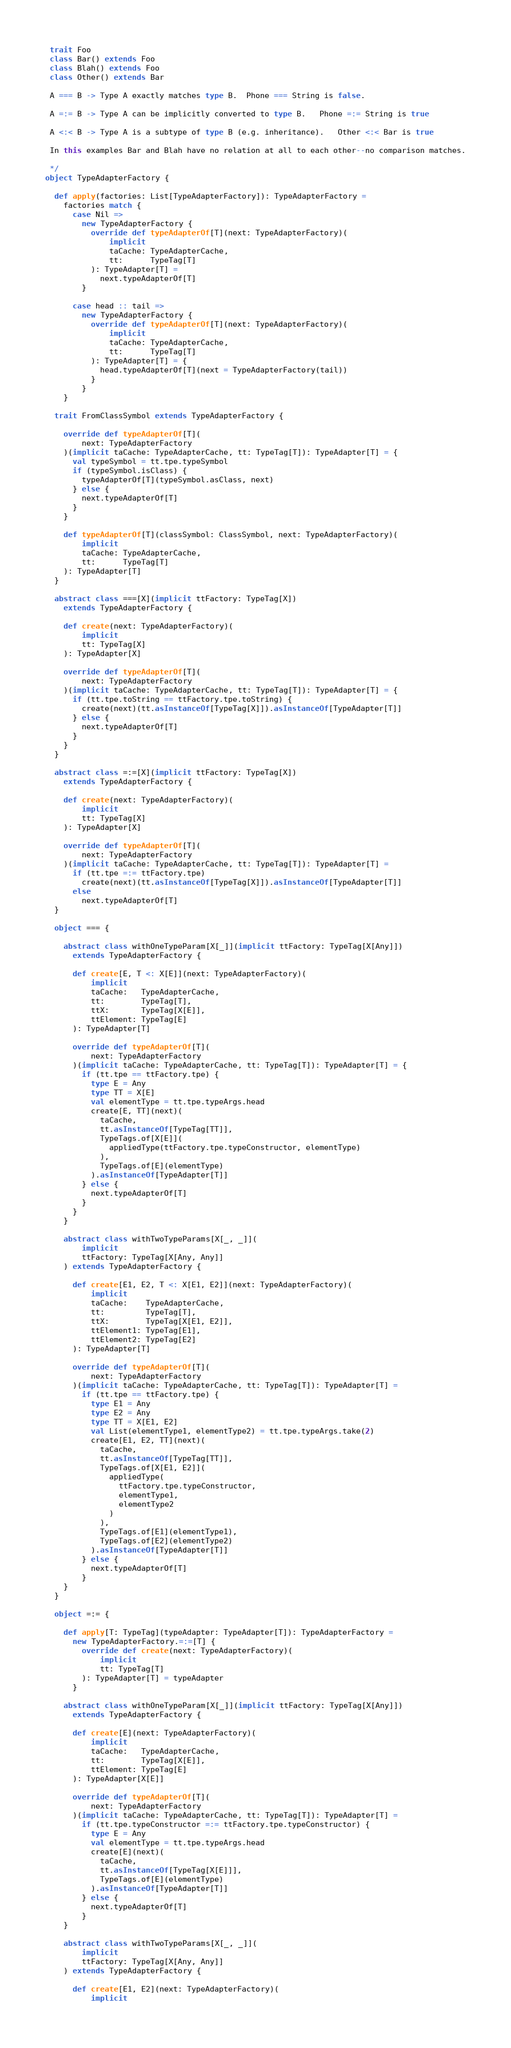<code> <loc_0><loc_0><loc_500><loc_500><_Scala_> trait Foo
 class Bar() extends Foo
 class Blah() extends Foo
 class Other() extends Bar

 A === B -> Type A exactly matches type B.  Phone === String is false.

 A =:= B -> Type A can be implicitly converted to type B.   Phone =:= String is true

 A <:< B -> Type A is a subtype of type B (e.g. inheritance).   Other <:< Bar is true

 In this examples Bar and Blah have no relation at all to each other--no comparison matches.

 */
object TypeAdapterFactory {

  def apply(factories: List[TypeAdapterFactory]): TypeAdapterFactory =
    factories match {
      case Nil =>
        new TypeAdapterFactory {
          override def typeAdapterOf[T](next: TypeAdapterFactory)(
              implicit
              taCache: TypeAdapterCache,
              tt:      TypeTag[T]
          ): TypeAdapter[T] =
            next.typeAdapterOf[T]
        }

      case head :: tail =>
        new TypeAdapterFactory {
          override def typeAdapterOf[T](next: TypeAdapterFactory)(
              implicit
              taCache: TypeAdapterCache,
              tt:      TypeTag[T]
          ): TypeAdapter[T] = {
            head.typeAdapterOf[T](next = TypeAdapterFactory(tail))
          }
        }
    }

  trait FromClassSymbol extends TypeAdapterFactory {

    override def typeAdapterOf[T](
        next: TypeAdapterFactory
    )(implicit taCache: TypeAdapterCache, tt: TypeTag[T]): TypeAdapter[T] = {
      val typeSymbol = tt.tpe.typeSymbol
      if (typeSymbol.isClass) {
        typeAdapterOf[T](typeSymbol.asClass, next)
      } else {
        next.typeAdapterOf[T]
      }
    }

    def typeAdapterOf[T](classSymbol: ClassSymbol, next: TypeAdapterFactory)(
        implicit
        taCache: TypeAdapterCache,
        tt:      TypeTag[T]
    ): TypeAdapter[T]
  }

  abstract class ===[X](implicit ttFactory: TypeTag[X])
    extends TypeAdapterFactory {

    def create(next: TypeAdapterFactory)(
        implicit
        tt: TypeTag[X]
    ): TypeAdapter[X]

    override def typeAdapterOf[T](
        next: TypeAdapterFactory
    )(implicit taCache: TypeAdapterCache, tt: TypeTag[T]): TypeAdapter[T] = {
      if (tt.tpe.toString == ttFactory.tpe.toString) {
        create(next)(tt.asInstanceOf[TypeTag[X]]).asInstanceOf[TypeAdapter[T]]
      } else {
        next.typeAdapterOf[T]
      }
    }
  }

  abstract class =:=[X](implicit ttFactory: TypeTag[X])
    extends TypeAdapterFactory {

    def create(next: TypeAdapterFactory)(
        implicit
        tt: TypeTag[X]
    ): TypeAdapter[X]

    override def typeAdapterOf[T](
        next: TypeAdapterFactory
    )(implicit taCache: TypeAdapterCache, tt: TypeTag[T]): TypeAdapter[T] =
      if (tt.tpe =:= ttFactory.tpe)
        create(next)(tt.asInstanceOf[TypeTag[X]]).asInstanceOf[TypeAdapter[T]]
      else
        next.typeAdapterOf[T]
  }

  object === {

    abstract class withOneTypeParam[X[_]](implicit ttFactory: TypeTag[X[Any]])
      extends TypeAdapterFactory {

      def create[E, T <: X[E]](next: TypeAdapterFactory)(
          implicit
          taCache:   TypeAdapterCache,
          tt:        TypeTag[T],
          ttX:       TypeTag[X[E]],
          ttElement: TypeTag[E]
      ): TypeAdapter[T]

      override def typeAdapterOf[T](
          next: TypeAdapterFactory
      )(implicit taCache: TypeAdapterCache, tt: TypeTag[T]): TypeAdapter[T] = {
        if (tt.tpe == ttFactory.tpe) {
          type E = Any
          type TT = X[E]
          val elementType = tt.tpe.typeArgs.head
          create[E, TT](next)(
            taCache,
            tt.asInstanceOf[TypeTag[TT]],
            TypeTags.of[X[E]](
              appliedType(ttFactory.tpe.typeConstructor, elementType)
            ),
            TypeTags.of[E](elementType)
          ).asInstanceOf[TypeAdapter[T]]
        } else {
          next.typeAdapterOf[T]
        }
      }
    }

    abstract class withTwoTypeParams[X[_, _]](
        implicit
        ttFactory: TypeTag[X[Any, Any]]
    ) extends TypeAdapterFactory {

      def create[E1, E2, T <: X[E1, E2]](next: TypeAdapterFactory)(
          implicit
          taCache:    TypeAdapterCache,
          tt:         TypeTag[T],
          ttX:        TypeTag[X[E1, E2]],
          ttElement1: TypeTag[E1],
          ttElement2: TypeTag[E2]
      ): TypeAdapter[T]

      override def typeAdapterOf[T](
          next: TypeAdapterFactory
      )(implicit taCache: TypeAdapterCache, tt: TypeTag[T]): TypeAdapter[T] =
        if (tt.tpe == ttFactory.tpe) {
          type E1 = Any
          type E2 = Any
          type TT = X[E1, E2]
          val List(elementType1, elementType2) = tt.tpe.typeArgs.take(2)
          create[E1, E2, TT](next)(
            taCache,
            tt.asInstanceOf[TypeTag[TT]],
            TypeTags.of[X[E1, E2]](
              appliedType(
                ttFactory.tpe.typeConstructor,
                elementType1,
                elementType2
              )
            ),
            TypeTags.of[E1](elementType1),
            TypeTags.of[E2](elementType2)
          ).asInstanceOf[TypeAdapter[T]]
        } else {
          next.typeAdapterOf[T]
        }
    }
  }

  object =:= {

    def apply[T: TypeTag](typeAdapter: TypeAdapter[T]): TypeAdapterFactory =
      new TypeAdapterFactory.=:=[T] {
        override def create(next: TypeAdapterFactory)(
            implicit
            tt: TypeTag[T]
        ): TypeAdapter[T] = typeAdapter
      }

    abstract class withOneTypeParam[X[_]](implicit ttFactory: TypeTag[X[Any]])
      extends TypeAdapterFactory {

      def create[E](next: TypeAdapterFactory)(
          implicit
          taCache:   TypeAdapterCache,
          tt:        TypeTag[X[E]],
          ttElement: TypeTag[E]
      ): TypeAdapter[X[E]]

      override def typeAdapterOf[T](
          next: TypeAdapterFactory
      )(implicit taCache: TypeAdapterCache, tt: TypeTag[T]): TypeAdapter[T] =
        if (tt.tpe.typeConstructor =:= ttFactory.tpe.typeConstructor) {
          type E = Any
          val elementType = tt.tpe.typeArgs.head
          create[E](next)(
            taCache,
            tt.asInstanceOf[TypeTag[X[E]]],
            TypeTags.of[E](elementType)
          ).asInstanceOf[TypeAdapter[T]]
        } else {
          next.typeAdapterOf[T]
        }
    }

    abstract class withTwoTypeParams[X[_, _]](
        implicit
        ttFactory: TypeTag[X[Any, Any]]
    ) extends TypeAdapterFactory {

      def create[E1, E2](next: TypeAdapterFactory)(
          implicit</code> 